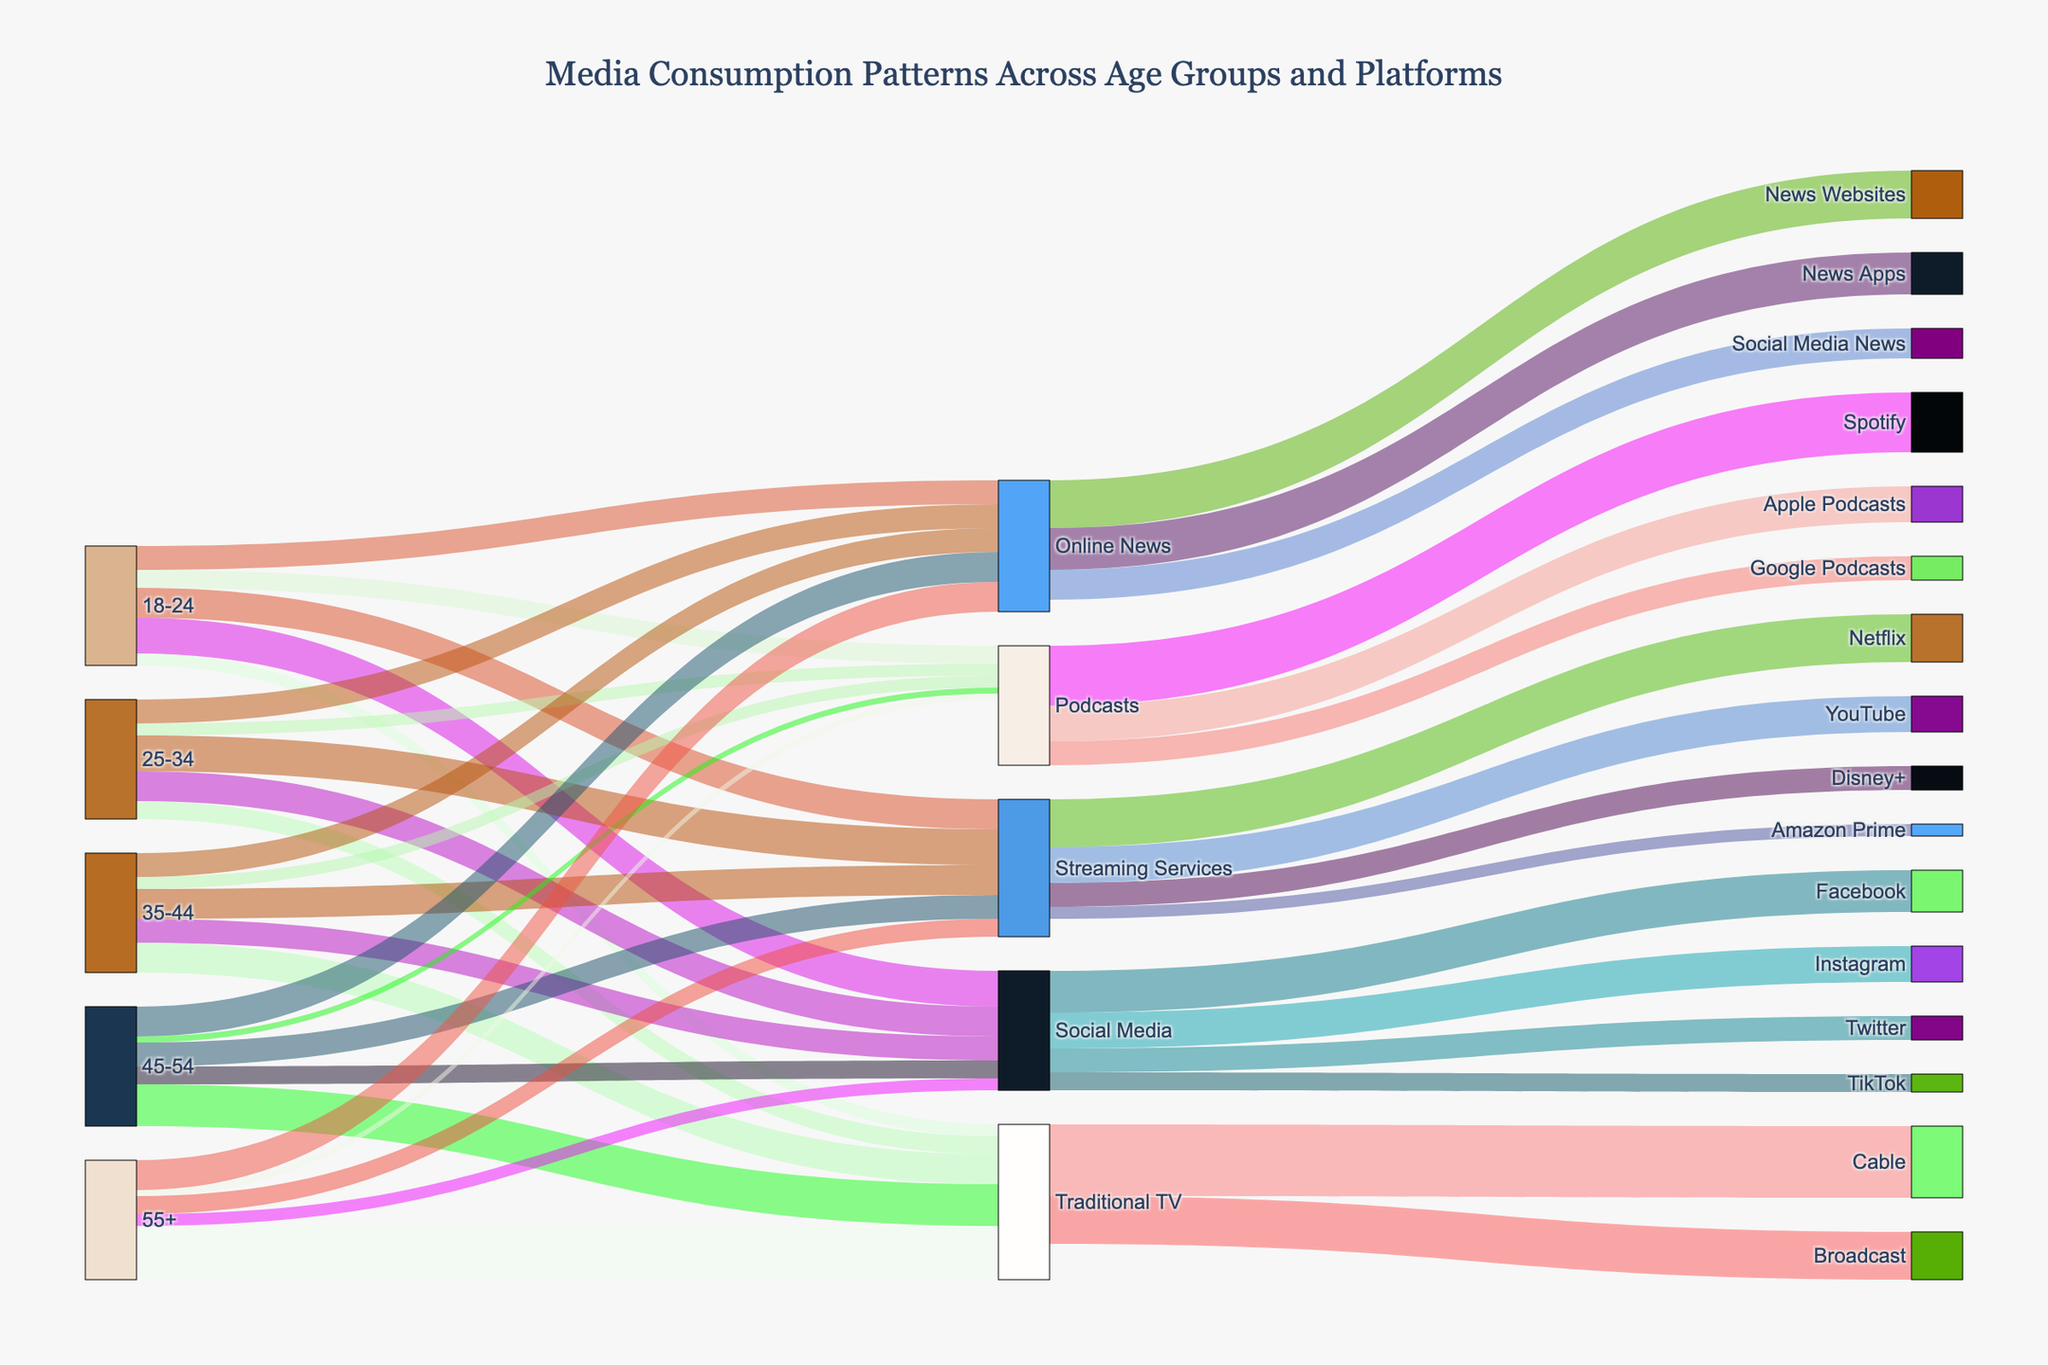How many different age groups are represented in the diagram? The connection from any of the given age groups (18-24, 25-34, 35-44, 45-54, and 55+) to their respective media consumption platforms indicates each age group. Counting these unique age groups gives us the total number.
Answer: 5 Which age group shows the highest consumption of Traditional TV? By observing the width of the connections between each age group and Traditional TV, we can identify that the 55+ age group has the widest connection to Traditional TV.
Answer: 55+ What is the combined consumption value of Social Media for all age groups? The values for each age group's connection to Social Media are 30 (18-24), 25 (25-34), 20 (35-44), 15 (45-54), and 10 (55+). Adding these values together gives us the total. 30 + 25 + 20 + 15 + 10 = 100.
Answer: 100 Among the streaming services, which platform has the highest consumption from users? Looking at the connection widths of Streaming Services to each platform, we see that Netflix has the widest connection.
Answer: Netflix Which medium has the lowest consumption value from age group 45-54? By comparing the connection values from the 45-54 age group to different platforms, we find the lowest value is for Podcasts, with a value of 5.
Answer: Podcasts What's the total consumption value for the Online News platform across all age groups? Summing up the values of all the connections from each age group to Online News: 20 (18-24) + 20 (25-34) + 20 (35-44) + 25 (45-54) + 25 (55+). The total is 110.
Answer: 110 Which social media platform has the smallest connection from Social Media? Observing the width of the connections from Social Media to various platforms shows that TikTok has the smallest connection.
Answer: TikTok 